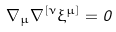Convert formula to latex. <formula><loc_0><loc_0><loc_500><loc_500>\nabla _ { \mu } \nabla ^ { [ \nu } \xi ^ { \mu ] } = 0</formula> 